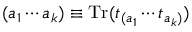<formula> <loc_0><loc_0><loc_500><loc_500>( a _ { 1 } \cdots a _ { k } ) \equiv T r ( t _ { ( a _ { 1 } } \cdots t _ { a _ { k } ) } )</formula> 